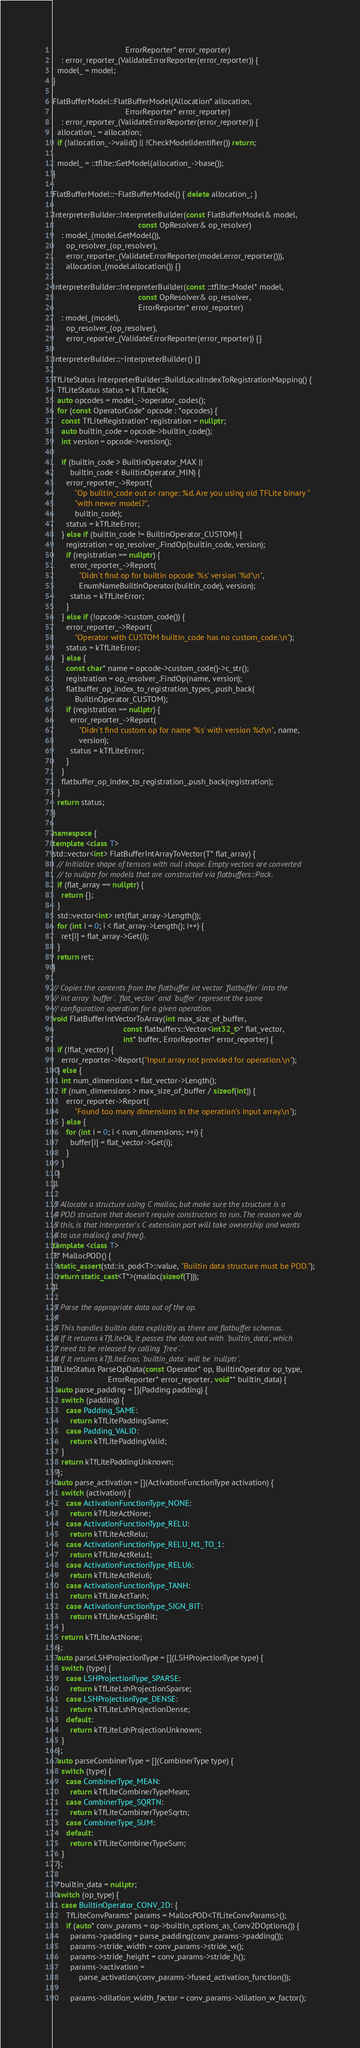<code> <loc_0><loc_0><loc_500><loc_500><_C++_>                                 ErrorReporter* error_reporter)
    : error_reporter_(ValidateErrorReporter(error_reporter)) {
  model_ = model;
}

FlatBufferModel::FlatBufferModel(Allocation* allocation,
                                 ErrorReporter* error_reporter)
    : error_reporter_(ValidateErrorReporter(error_reporter)) {
  allocation_ = allocation;
  if (!allocation_->valid() || !CheckModelIdentifier()) return;

  model_ = ::tflite::GetModel(allocation_->base());
}

FlatBufferModel::~FlatBufferModel() { delete allocation_; }

InterpreterBuilder::InterpreterBuilder(const FlatBufferModel& model,
                                       const OpResolver& op_resolver)
    : model_(model.GetModel()),
      op_resolver_(op_resolver),
      error_reporter_(ValidateErrorReporter(model.error_reporter())),
      allocation_(model.allocation()) {}

InterpreterBuilder::InterpreterBuilder(const ::tflite::Model* model,
                                       const OpResolver& op_resolver,
                                       ErrorReporter* error_reporter)
    : model_(model),
      op_resolver_(op_resolver),
      error_reporter_(ValidateErrorReporter(error_reporter)) {}

InterpreterBuilder::~InterpreterBuilder() {}

TfLiteStatus InterpreterBuilder::BuildLocalIndexToRegistrationMapping() {
  TfLiteStatus status = kTfLiteOk;
  auto opcodes = model_->operator_codes();
  for (const OperatorCode* opcode : *opcodes) {
    const TfLiteRegistration* registration = nullptr;
    auto builtin_code = opcode->builtin_code();
    int version = opcode->version();

    if (builtin_code > BuiltinOperator_MAX ||
        builtin_code < BuiltinOperator_MIN) {
      error_reporter_->Report(
          "Op builtin_code out or range: %d. Are you using old TFLite binary "
          "with newer model?",
          builtin_code);
      status = kTfLiteError;
    } else if (builtin_code != BuiltinOperator_CUSTOM) {
      registration = op_resolver_.FindOp(builtin_code, version);
      if (registration == nullptr) {
        error_reporter_->Report(
            "Didn't find op for builtin opcode '%s' version '%d'\n",
            EnumNameBuiltinOperator(builtin_code), version);
        status = kTfLiteError;
      }
    } else if (!opcode->custom_code()) {
      error_reporter_->Report(
          "Operator with CUSTOM builtin_code has no custom_code.\n");
      status = kTfLiteError;
    } else {
      const char* name = opcode->custom_code()->c_str();
      registration = op_resolver_.FindOp(name, version);
      flatbuffer_op_index_to_registration_types_.push_back(
          BuiltinOperator_CUSTOM);
      if (registration == nullptr) {
        error_reporter_->Report(
            "Didn't find custom op for name '%s' with version %d\n", name,
            version);
        status = kTfLiteError;
      }
    }
    flatbuffer_op_index_to_registration_.push_back(registration);
  }
  return status;
}

namespace {
template <class T>
std::vector<int> FlatBufferIntArrayToVector(T* flat_array) {
  // Initialize shape of tensors with null shape. Empty vectors are converted
  // to nullptr for models that are constructed via flatbuffers::Pack.
  if (flat_array == nullptr) {
    return {};
  }
  std::vector<int> ret(flat_array->Length());
  for (int i = 0; i < flat_array->Length(); i++) {
    ret[i] = flat_array->Get(i);
  }
  return ret;
}

// Copies the contents from the flatbuffer int vector `flatbuffer` into the
// int array `buffer`. `flat_vector` and `buffer` represent the same
// configuration operation for a given operation.
void FlatBufferIntVectorToArray(int max_size_of_buffer,
                                const flatbuffers::Vector<int32_t>* flat_vector,
                                int* buffer, ErrorReporter* error_reporter) {
  if (!flat_vector) {
    error_reporter->Report("Input array not provided for operation.\n");
  } else {
    int num_dimensions = flat_vector->Length();
    if (num_dimensions > max_size_of_buffer / sizeof(int)) {
      error_reporter->Report(
          "Found too many dimensions in the operation's input array.\n");
    } else {
      for (int i = 0; i < num_dimensions; ++i) {
        buffer[i] = flat_vector->Get(i);
      }
    }
  }
}

// Allocate a structure using C malloc, but make sure the structure is a
// POD structure that doesn't require constructors to run. The reason we do
// this, is that Interpreter's C extension part will take ownership and wants
// to use malloc() and free().
template <class T>
T* MallocPOD() {
  static_assert(std::is_pod<T>::value, "Builtin data structure must be POD.");
  return static_cast<T*>(malloc(sizeof(T)));
}

// Parse the appropriate data out of the op.
//
// This handles builtin data explicitly as there are flatbuffer schemas.
// If it returns kTfLiteOk, it passes the data out with `builtin_data`, which
// need to be released by calling `free`.`
// If it returns kTfLiteError, `builtin_data` will be `nullptr`.
TfLiteStatus ParseOpData(const Operator* op, BuiltinOperator op_type,
                         ErrorReporter* error_reporter, void** builtin_data) {
  auto parse_padding = [](Padding padding) {
    switch (padding) {
      case Padding_SAME:
        return kTfLitePaddingSame;
      case Padding_VALID:
        return kTfLitePaddingValid;
    }
    return kTfLitePaddingUnknown;
  };
  auto parse_activation = [](ActivationFunctionType activation) {
    switch (activation) {
      case ActivationFunctionType_NONE:
        return kTfLiteActNone;
      case ActivationFunctionType_RELU:
        return kTfLiteActRelu;
      case ActivationFunctionType_RELU_N1_TO_1:
        return kTfLiteActRelu1;
      case ActivationFunctionType_RELU6:
        return kTfLiteActRelu6;
      case ActivationFunctionType_TANH:
        return kTfLiteActTanh;
      case ActivationFunctionType_SIGN_BIT:
        return kTfLiteActSignBit;
    }
    return kTfLiteActNone;
  };
  auto parseLSHProjectionType = [](LSHProjectionType type) {
    switch (type) {
      case LSHProjectionType_SPARSE:
        return kTfLiteLshProjectionSparse;
      case LSHProjectionType_DENSE:
        return kTfLiteLshProjectionDense;
      default:
        return kTfLiteLshProjectionUnknown;
    }
  };
  auto parseCombinerType = [](CombinerType type) {
    switch (type) {
      case CombinerType_MEAN:
        return kTfLiteCombinerTypeMean;
      case CombinerType_SQRTN:
        return kTfLiteCombinerTypeSqrtn;
      case CombinerType_SUM:
      default:
        return kTfLiteCombinerTypeSum;
    }
  };

  *builtin_data = nullptr;
  switch (op_type) {
    case BuiltinOperator_CONV_2D: {
      TfLiteConvParams* params = MallocPOD<TfLiteConvParams>();
      if (auto* conv_params = op->builtin_options_as_Conv2DOptions()) {
        params->padding = parse_padding(conv_params->padding());
        params->stride_width = conv_params->stride_w();
        params->stride_height = conv_params->stride_h();
        params->activation =
            parse_activation(conv_params->fused_activation_function());

        params->dilation_width_factor = conv_params->dilation_w_factor();</code> 